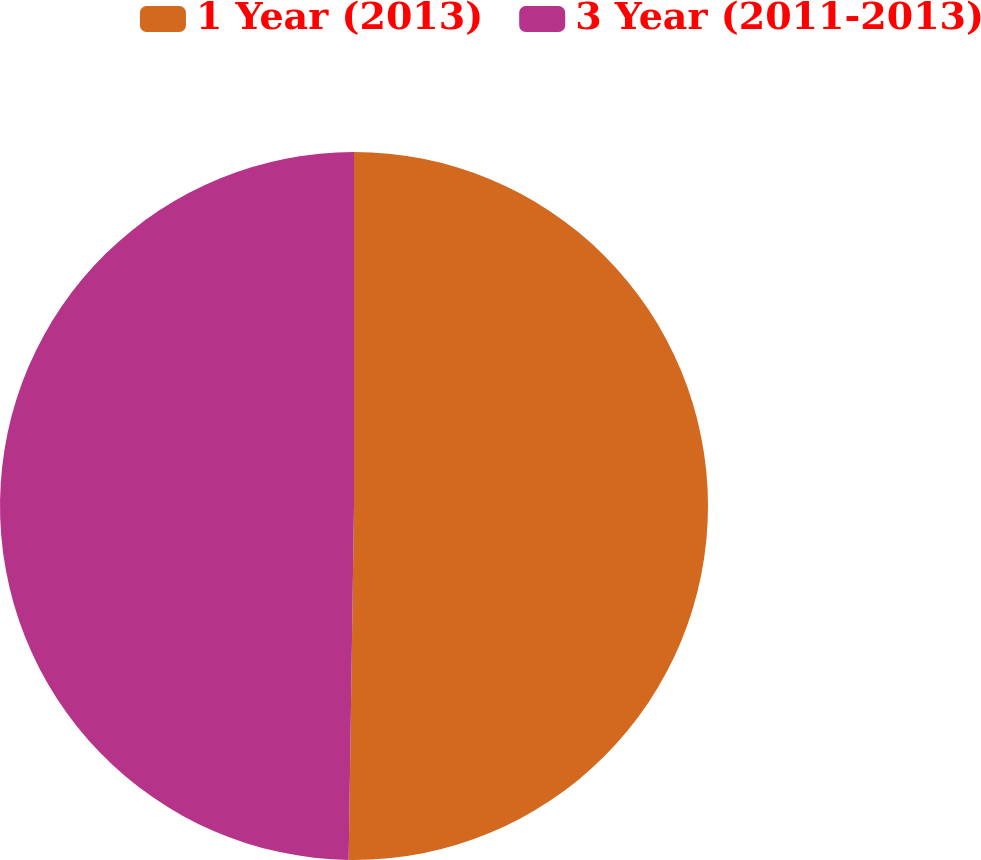Convert chart. <chart><loc_0><loc_0><loc_500><loc_500><pie_chart><fcel>1 Year (2013)<fcel>3 Year (2011-2013)<nl><fcel>50.24%<fcel>49.76%<nl></chart> 